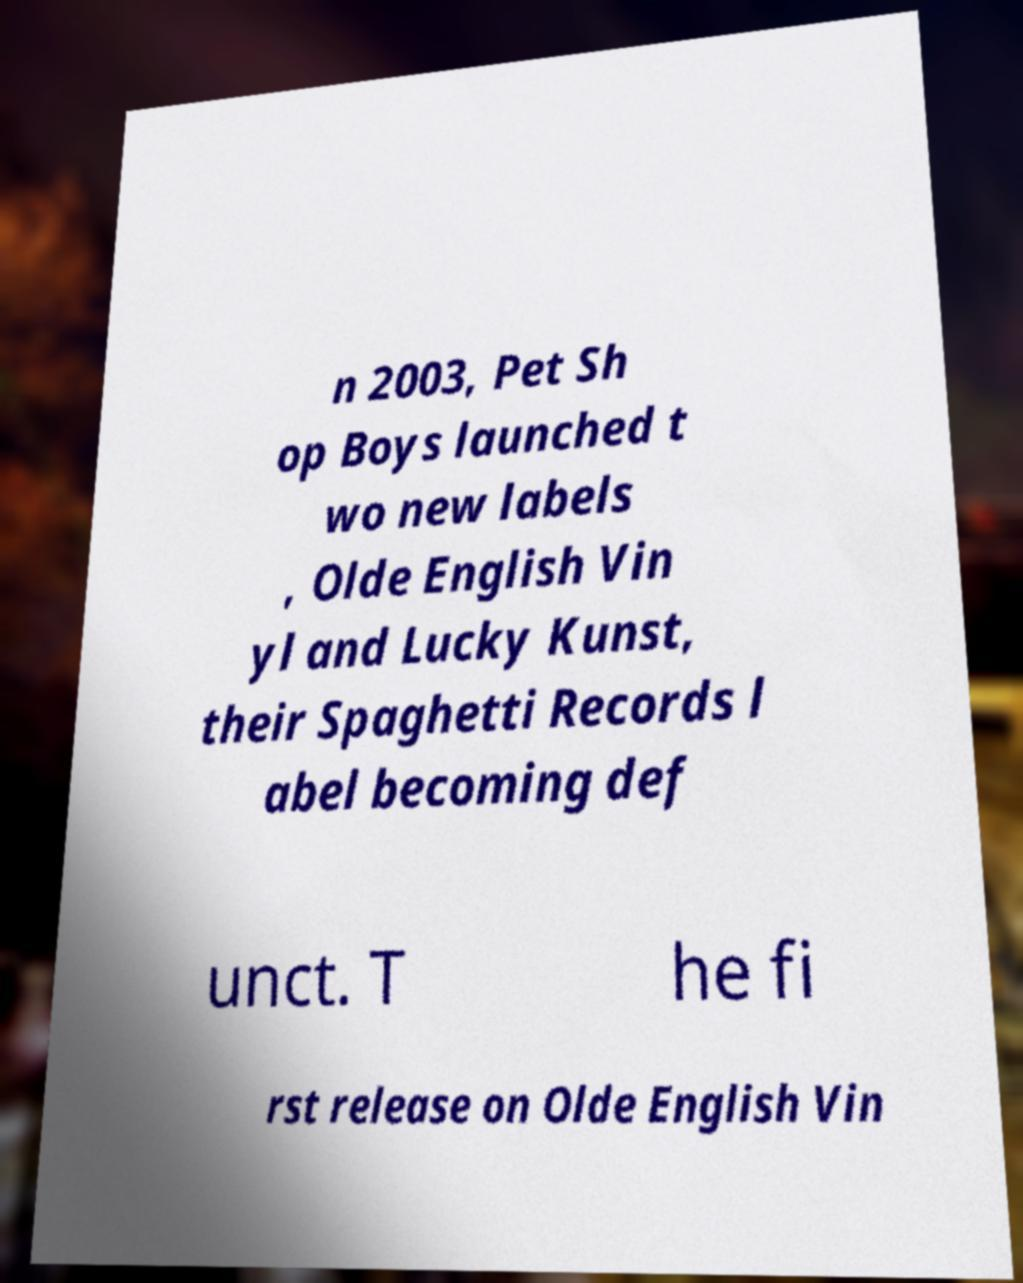Could you extract and type out the text from this image? n 2003, Pet Sh op Boys launched t wo new labels , Olde English Vin yl and Lucky Kunst, their Spaghetti Records l abel becoming def unct. T he fi rst release on Olde English Vin 